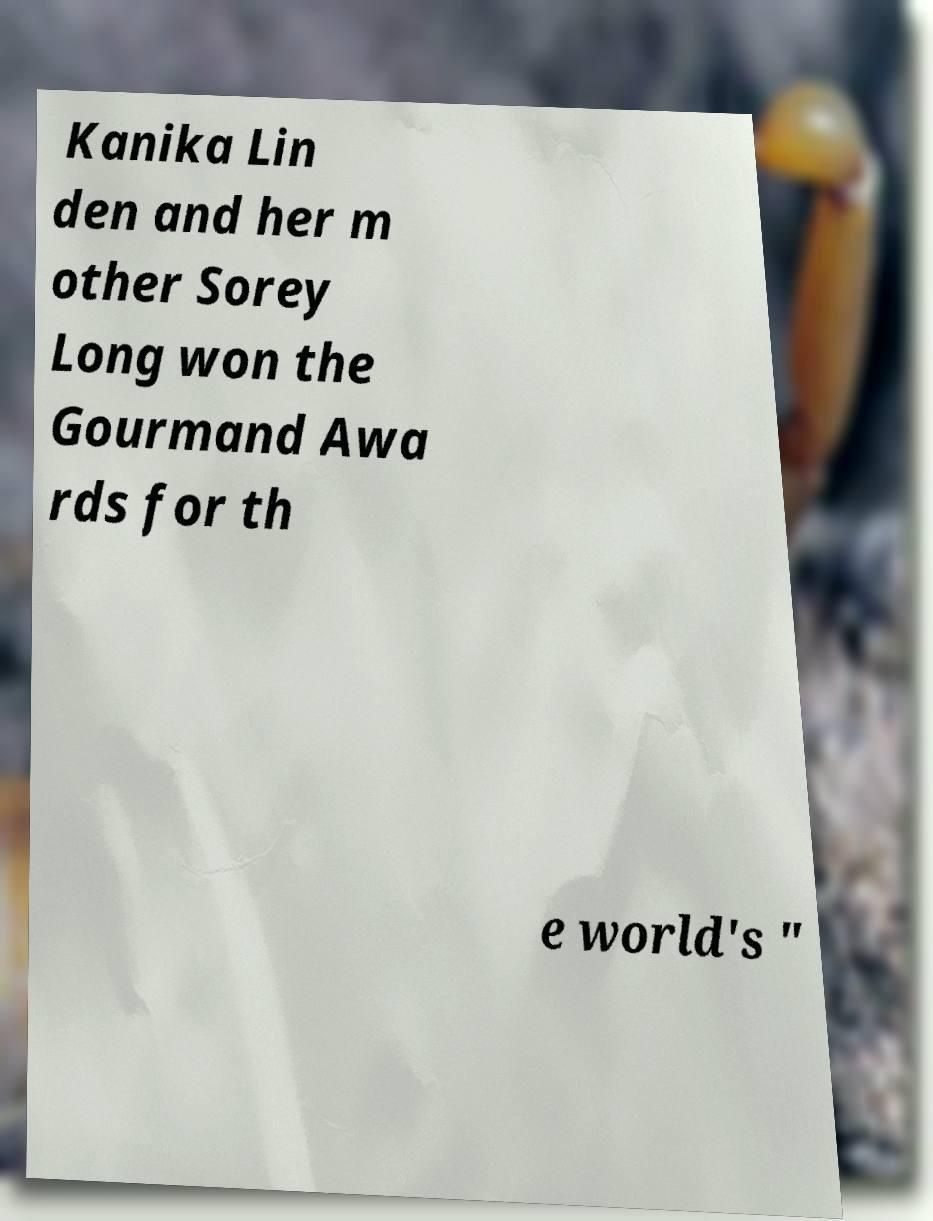Could you assist in decoding the text presented in this image and type it out clearly? Kanika Lin den and her m other Sorey Long won the Gourmand Awa rds for th e world's " 